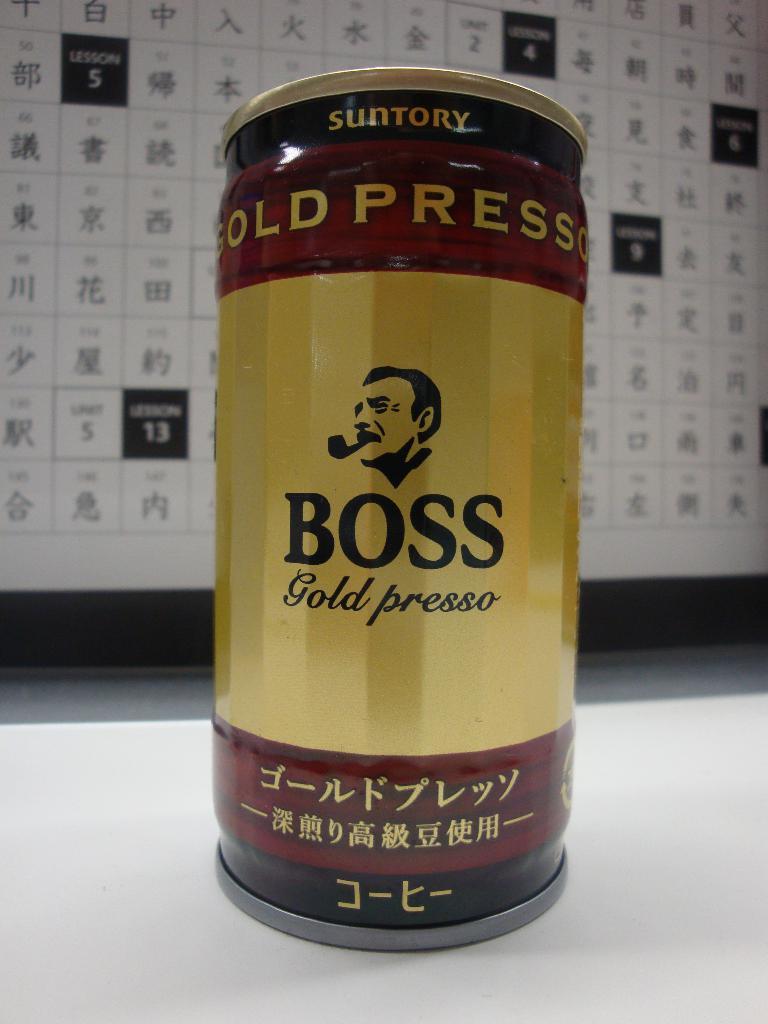What kind of espresso is it?
Your answer should be compact. Gold presso. 